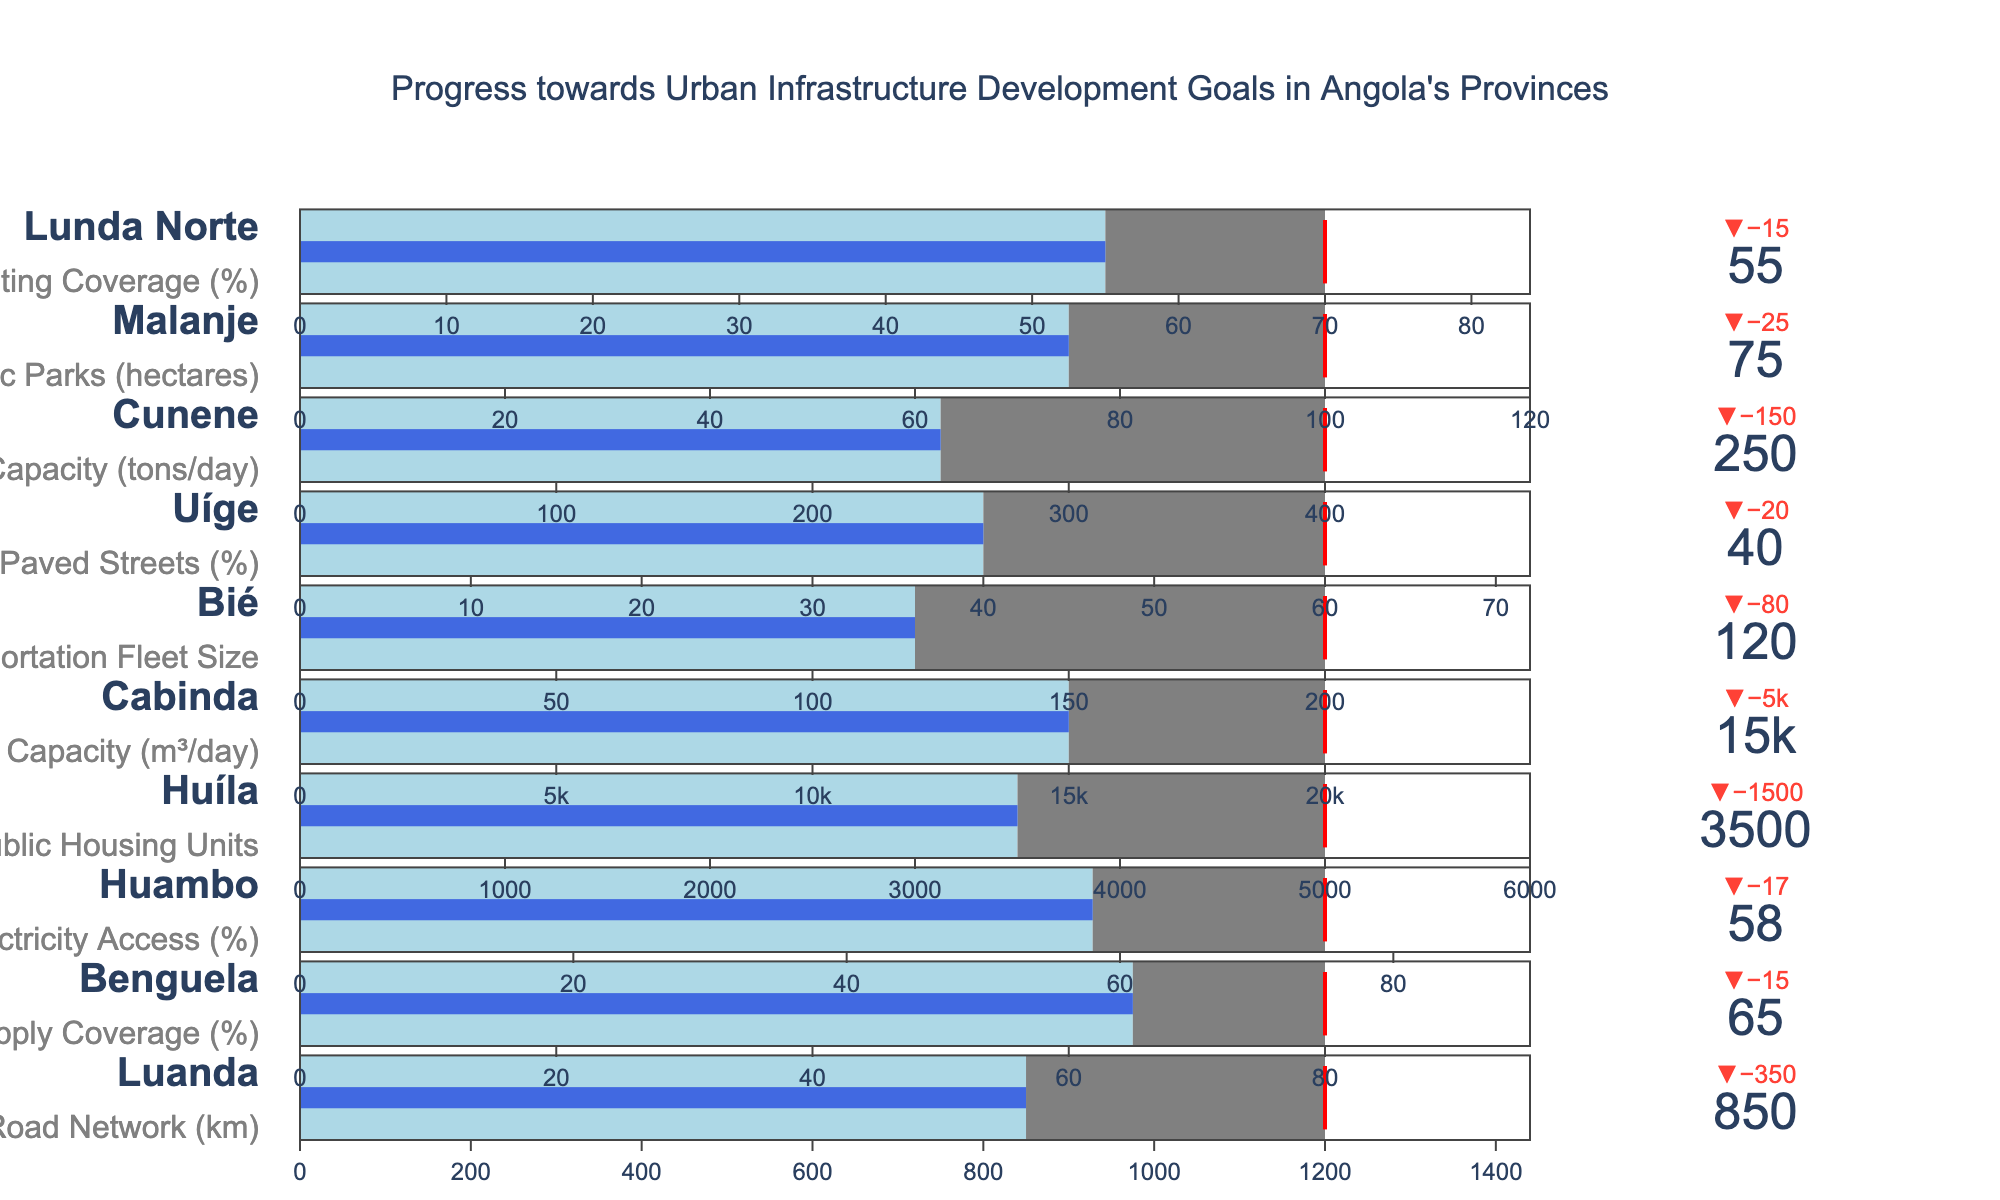Which province has the highest percentage of street lighting coverage? By looking at the bullet chart, we identify the actual values for each province concerning their specific goals. The province with the highest percentage for street lighting coverage as listed is Lunda Norte with 55%.
Answer: Lunda Norte How many kilometers of the urban road network have been developed in Luanda? To find the developed kilometers of the urban road network in Luanda, look at Luanda's actual value. It is shown as 850.
Answer: 850 Which province has the largest gap to fill to meet its target for public housing units? Calculate the differences between actual values and their targets for each province. Huíla's gap is the largest with a difference of 1500 units (5000 - 3500).
Answer: Huíla What is the target for electricity access percentage in Huambo? The target value for Huambo is displayed next to its goal of electricity access percentage. It is 75%.
Answer: 75% Which province is closest to achieving its waste management capacity target in tons/day? Assess the difference between the actual and target values for each province's waste management capacity. Cunene has the smallest difference with actual 250 tons/day and target 400 tons/day, so it is the closest.
Answer: Cunene What is the sum of the actual paved streets percentages in Bié and Uíge? Add the actual paved streets percentages for Bié (0%, not listed explicitly but inferred as 0 since it's not indicated) and Uíge (40%) to obtain the sum, which is 40%.
Answer: 40% Compare the actual values of public parks (hectares) and street lighting coverage (%) for provinces Malanje and Lunda Norte. Which has a higher value? Review the figure for actual values of public parks (Malanje, 75 hectares) and street lighting coverage (Lunda Norte, 55%). Malanje has the higher actual value.
Answer: Malanje Which goal has the smallest gap to the target in terms of absolute value? Determine the absolute difference between actual and target values for each goal. The smallest gap is for Benguela's water supply coverage (80% - 65% = 15%).
Answer: Water Supply Coverage in Benguela What percentage of the target has the urban road network in Luanda achieved? Calculate the percentage by dividing the actual value by the target and then multiply by 100: (850 / 1200) * 100 = 70.83%.
Answer: 70.83% Which two provinces have the same goal but different targets and actuals? Compare each province's goals to identify any that share the same goal. Cabinda and Cunene both have goals related to capacity but with different targets and actuals, sewage treatment, and waste management respectively.
Answer: Cabinda and Cunene 